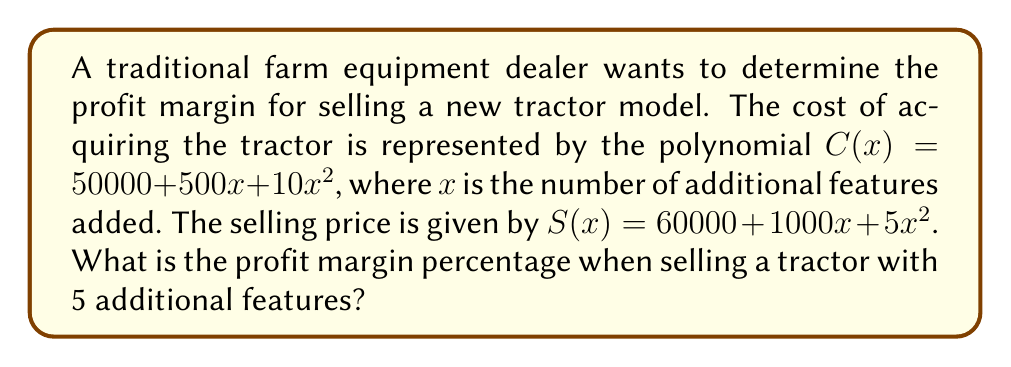Solve this math problem. To solve this problem, we'll follow these steps:

1. Calculate the cost of the tractor with 5 additional features:
   $$C(5) = 50000 + 500(5) + 10(5^2)$$
   $$C(5) = 50000 + 2500 + 250 = 52750$$

2. Calculate the selling price of the tractor with 5 additional features:
   $$S(5) = 60000 + 1000(5) + 5(5^2)$$
   $$S(5) = 60000 + 5000 + 125 = 65125$$

3. Calculate the profit:
   $$\text{Profit} = S(5) - C(5) = 65125 - 52750 = 12375$$

4. Calculate the profit margin percentage:
   $$\text{Profit Margin} = \frac{\text{Profit}}{\text{Selling Price}} \times 100\%$$
   $$\text{Profit Margin} = \frac{12375}{65125} \times 100\% \approx 19.00\%$$
Answer: 19.00% 